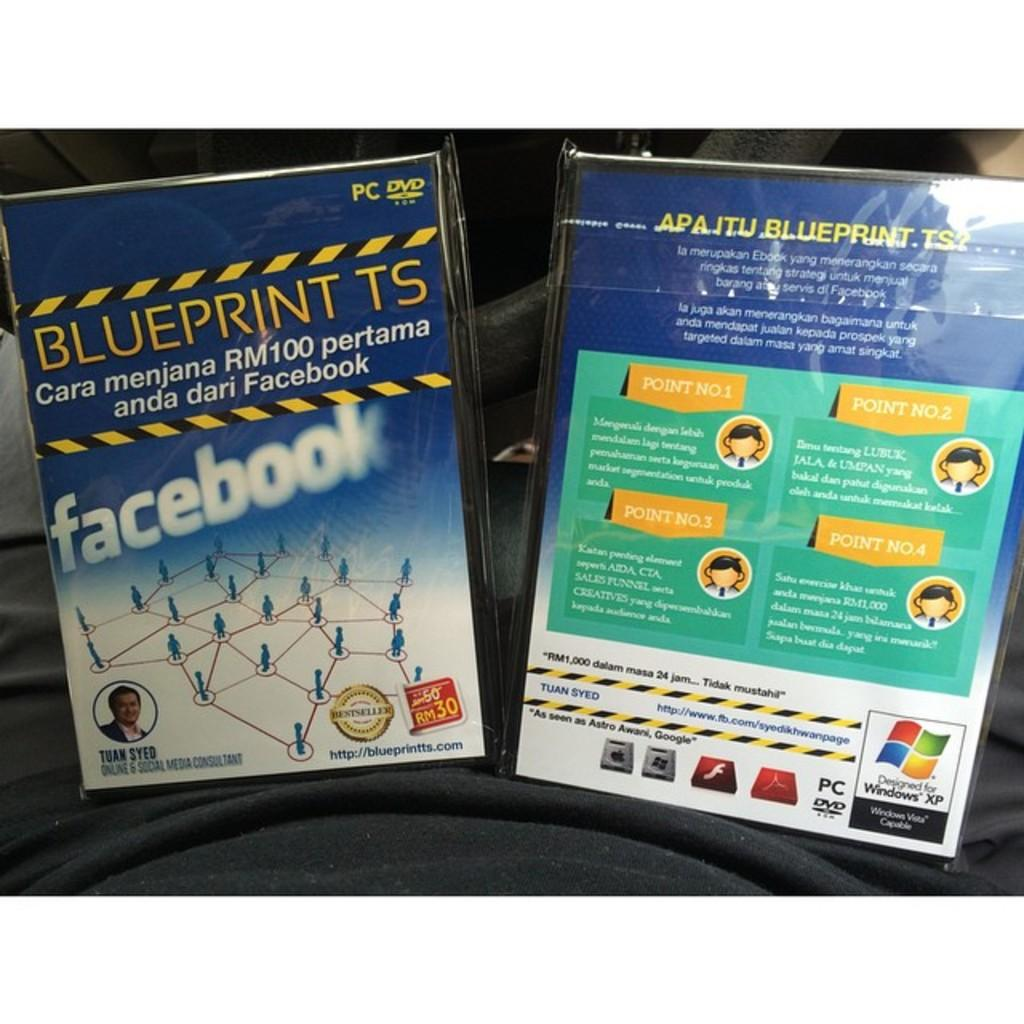<image>
Render a clear and concise summary of the photo. DVD that says Blueprint TS and the social media Facebook on the bottom. 